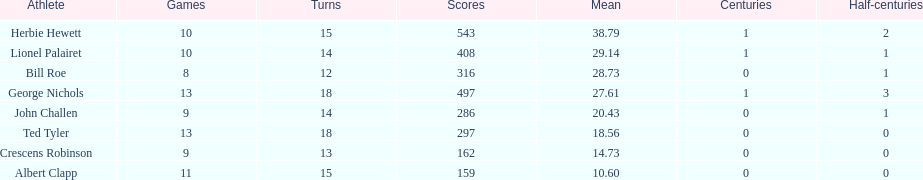Name a player whose average was above 25. Herbie Hewett. 